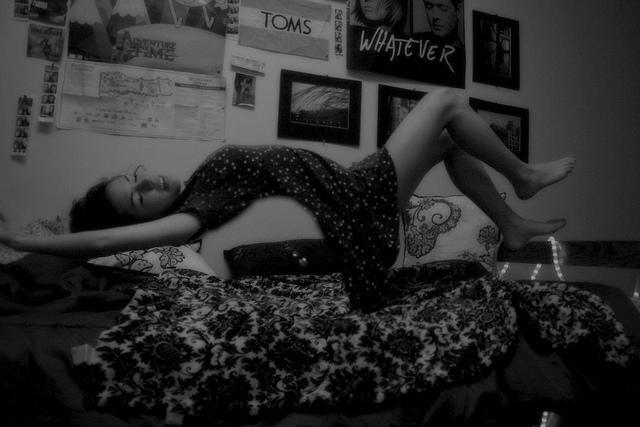How many beds are there?
Give a very brief answer. 1. How many cows are facing the camera?
Give a very brief answer. 0. 